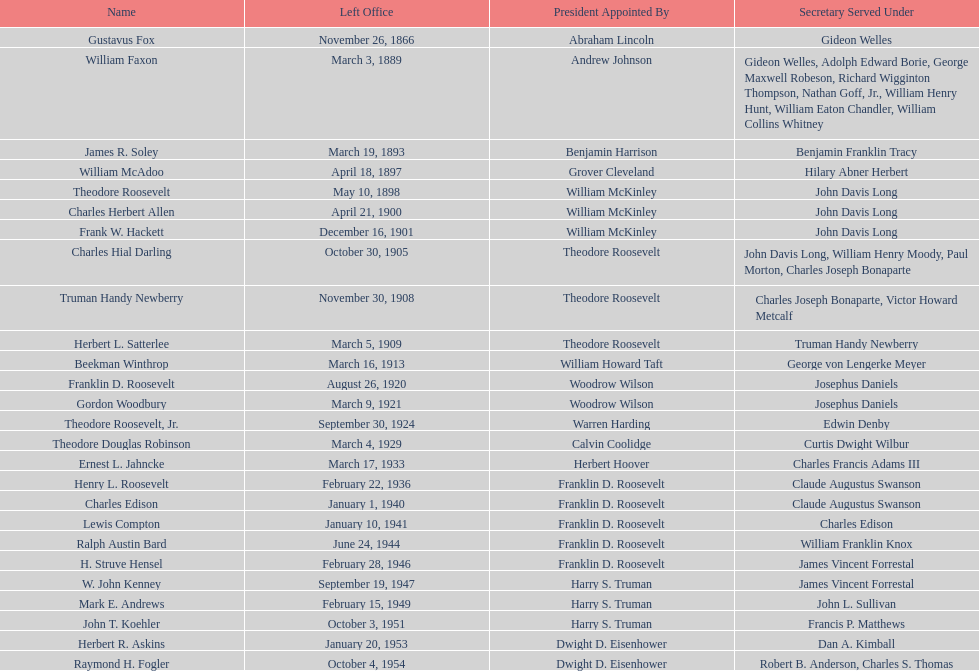When did raymond h. fogler leave the office of assistant secretary of the navy? October 4, 1954. 